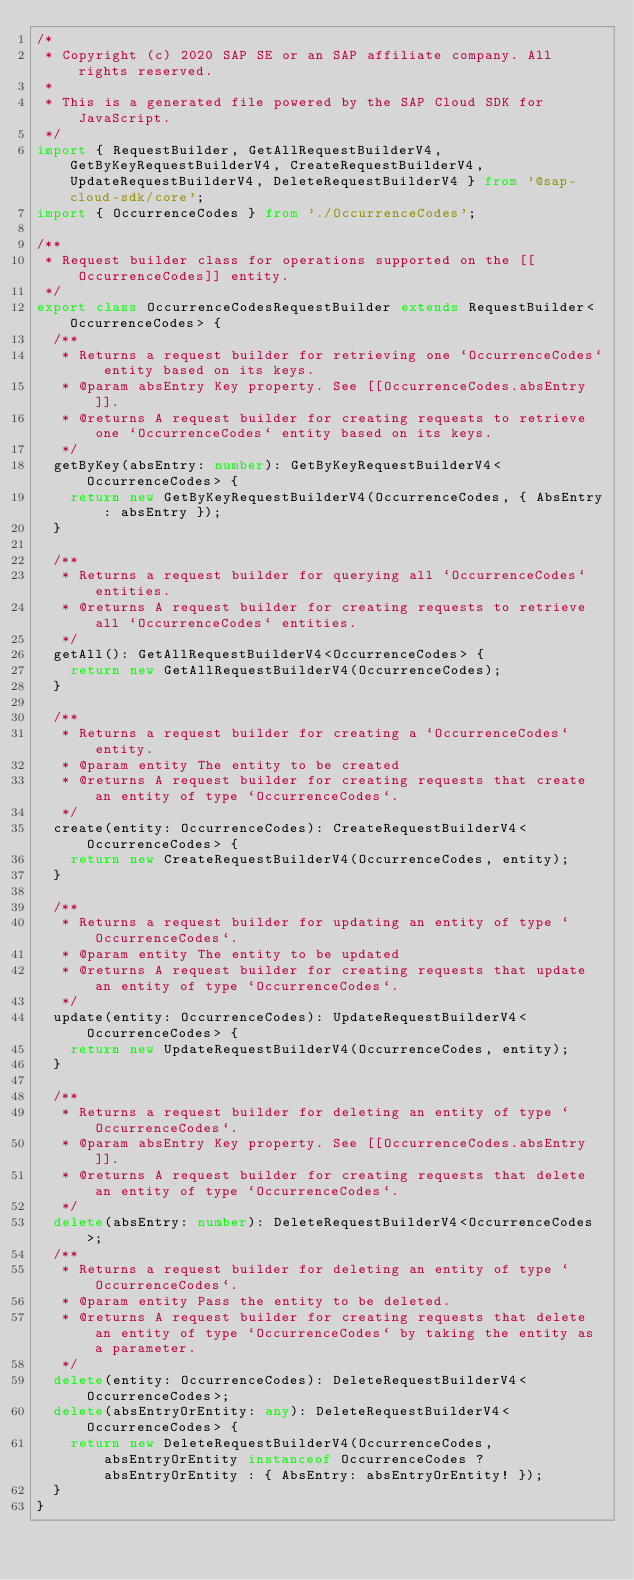<code> <loc_0><loc_0><loc_500><loc_500><_TypeScript_>/*
 * Copyright (c) 2020 SAP SE or an SAP affiliate company. All rights reserved.
 *
 * This is a generated file powered by the SAP Cloud SDK for JavaScript.
 */
import { RequestBuilder, GetAllRequestBuilderV4, GetByKeyRequestBuilderV4, CreateRequestBuilderV4, UpdateRequestBuilderV4, DeleteRequestBuilderV4 } from '@sap-cloud-sdk/core';
import { OccurrenceCodes } from './OccurrenceCodes';

/**
 * Request builder class for operations supported on the [[OccurrenceCodes]] entity.
 */
export class OccurrenceCodesRequestBuilder extends RequestBuilder<OccurrenceCodes> {
  /**
   * Returns a request builder for retrieving one `OccurrenceCodes` entity based on its keys.
   * @param absEntry Key property. See [[OccurrenceCodes.absEntry]].
   * @returns A request builder for creating requests to retrieve one `OccurrenceCodes` entity based on its keys.
   */
  getByKey(absEntry: number): GetByKeyRequestBuilderV4<OccurrenceCodes> {
    return new GetByKeyRequestBuilderV4(OccurrenceCodes, { AbsEntry: absEntry });
  }

  /**
   * Returns a request builder for querying all `OccurrenceCodes` entities.
   * @returns A request builder for creating requests to retrieve all `OccurrenceCodes` entities.
   */
  getAll(): GetAllRequestBuilderV4<OccurrenceCodes> {
    return new GetAllRequestBuilderV4(OccurrenceCodes);
  }

  /**
   * Returns a request builder for creating a `OccurrenceCodes` entity.
   * @param entity The entity to be created
   * @returns A request builder for creating requests that create an entity of type `OccurrenceCodes`.
   */
  create(entity: OccurrenceCodes): CreateRequestBuilderV4<OccurrenceCodes> {
    return new CreateRequestBuilderV4(OccurrenceCodes, entity);
  }

  /**
   * Returns a request builder for updating an entity of type `OccurrenceCodes`.
   * @param entity The entity to be updated
   * @returns A request builder for creating requests that update an entity of type `OccurrenceCodes`.
   */
  update(entity: OccurrenceCodes): UpdateRequestBuilderV4<OccurrenceCodes> {
    return new UpdateRequestBuilderV4(OccurrenceCodes, entity);
  }

  /**
   * Returns a request builder for deleting an entity of type `OccurrenceCodes`.
   * @param absEntry Key property. See [[OccurrenceCodes.absEntry]].
   * @returns A request builder for creating requests that delete an entity of type `OccurrenceCodes`.
   */
  delete(absEntry: number): DeleteRequestBuilderV4<OccurrenceCodes>;
  /**
   * Returns a request builder for deleting an entity of type `OccurrenceCodes`.
   * @param entity Pass the entity to be deleted.
   * @returns A request builder for creating requests that delete an entity of type `OccurrenceCodes` by taking the entity as a parameter.
   */
  delete(entity: OccurrenceCodes): DeleteRequestBuilderV4<OccurrenceCodes>;
  delete(absEntryOrEntity: any): DeleteRequestBuilderV4<OccurrenceCodes> {
    return new DeleteRequestBuilderV4(OccurrenceCodes, absEntryOrEntity instanceof OccurrenceCodes ? absEntryOrEntity : { AbsEntry: absEntryOrEntity! });
  }
}
</code> 